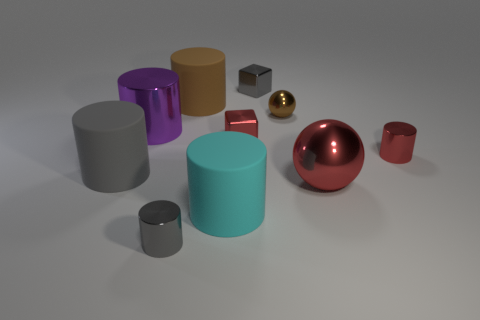Subtract 2 cylinders. How many cylinders are left? 4 Subtract all large metallic cylinders. How many cylinders are left? 5 Subtract all red cylinders. How many cylinders are left? 5 Subtract all cyan cylinders. Subtract all cyan cubes. How many cylinders are left? 5 Subtract all cylinders. How many objects are left? 4 Add 2 big red metallic cylinders. How many big red metallic cylinders exist? 2 Subtract 1 gray blocks. How many objects are left? 9 Subtract all big yellow cylinders. Subtract all tiny gray metallic things. How many objects are left? 8 Add 4 matte things. How many matte things are left? 7 